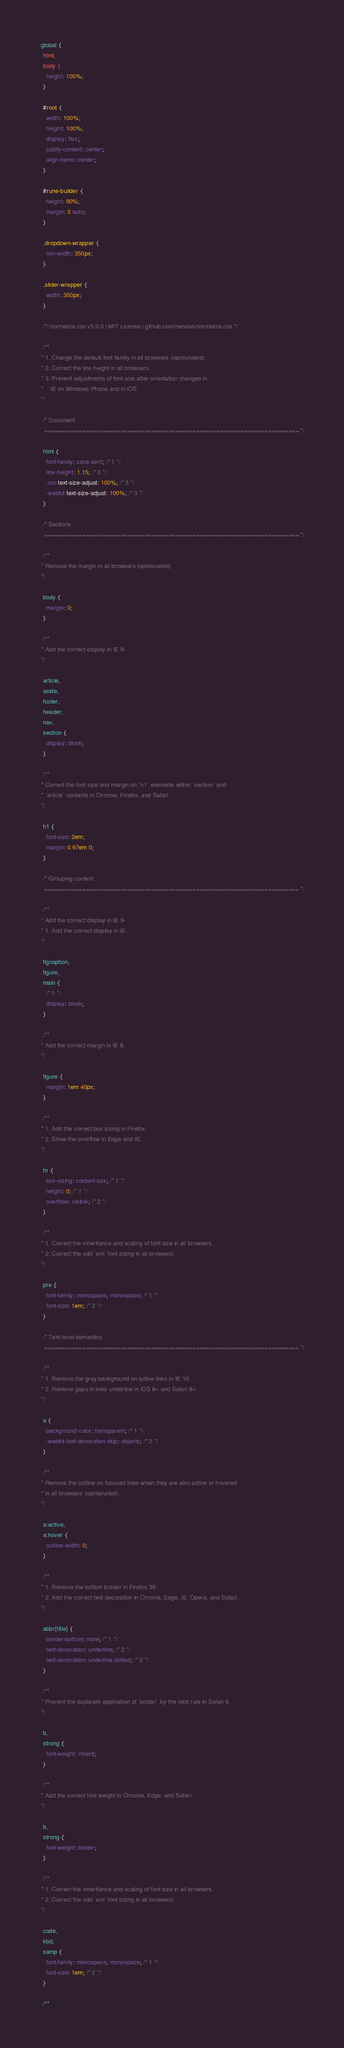<code> <loc_0><loc_0><loc_500><loc_500><_CSS_>:global {
  html,
  body {
    height: 100%;
  }

  #root {
    width: 100%;
    height: 100%;
    display: flex;
    justify-content: center;
    align-items: center;
  }

  #rune-builder {
    height: 90%;
    margin: 0 auto;
  }

  .dropdown-wrapper {
    min-width: 350px;
  }

  .slider-wrapper {
    width: 350px;
  }

  /*! normalize.css v5.0.0 | MIT License | github.com/necolas/normalize.css */

  /**
 * 1. Change the default font family in all browsers (opinionated).
 * 2. Correct the line height in all browsers.
 * 3. Prevent adjustments of font size after orientation changes in
 *    IE on Windows Phone and in iOS.
 */

  /* Document
   ========================================================================== */

  html {
    font-family: sans-serif; /* 1 */
    line-height: 1.15; /* 2 */
    -ms-text-size-adjust: 100%; /* 3 */
    -webkit-text-size-adjust: 100%; /* 3 */
  }

  /* Sections
   ========================================================================== */

  /**
 * Remove the margin in all browsers (opinionated).
 */

  body {
    margin: 0;
  }

  /**
 * Add the correct display in IE 9-.
 */

  article,
  aside,
  footer,
  header,
  nav,
  section {
    display: block;
  }

  /**
 * Correct the font size and margin on `h1` elements within `section` and
 * `article` contexts in Chrome, Firefox, and Safari.
 */

  h1 {
    font-size: 2em;
    margin: 0.67em 0;
  }

  /* Grouping content
   ========================================================================== */

  /**
 * Add the correct display in IE 9-.
 * 1. Add the correct display in IE.
 */

  figcaption,
  figure,
  main {
    /* 1 */
    display: block;
  }

  /**
 * Add the correct margin in IE 8.
 */

  figure {
    margin: 1em 40px;
  }

  /**
 * 1. Add the correct box sizing in Firefox.
 * 2. Show the overflow in Edge and IE.
 */

  hr {
    box-sizing: content-box; /* 1 */
    height: 0; /* 1 */
    overflow: visible; /* 2 */
  }

  /**
 * 1. Correct the inheritance and scaling of font size in all browsers.
 * 2. Correct the odd `em` font sizing in all browsers.
 */

  pre {
    font-family: monospace, monospace; /* 1 */
    font-size: 1em; /* 2 */
  }

  /* Text-level semantics
   ========================================================================== */

  /**
 * 1. Remove the gray background on active links in IE 10.
 * 2. Remove gaps in links underline in iOS 8+ and Safari 8+.
 */

  a {
    background-color: transparent; /* 1 */
    -webkit-text-decoration-skip: objects; /* 2 */
  }

  /**
 * Remove the outline on focused links when they are also active or hovered
 * in all browsers (opinionated).
 */

  a:active,
  a:hover {
    outline-width: 0;
  }

  /**
 * 1. Remove the bottom border in Firefox 39-.
 * 2. Add the correct text decoration in Chrome, Edge, IE, Opera, and Safari.
 */

  abbr[title] {
    border-bottom: none; /* 1 */
    text-decoration: underline; /* 2 */
    text-decoration: underline dotted; /* 2 */
  }

  /**
 * Prevent the duplicate application of `bolder` by the next rule in Safari 6.
 */

  b,
  strong {
    font-weight: inherit;
  }

  /**
 * Add the correct font weight in Chrome, Edge, and Safari.
 */

  b,
  strong {
    font-weight: bolder;
  }

  /**
 * 1. Correct the inheritance and scaling of font size in all browsers.
 * 2. Correct the odd `em` font sizing in all browsers.
 */

  code,
  kbd,
  samp {
    font-family: monospace, monospace; /* 1 */
    font-size: 1em; /* 2 */
  }

  /**</code> 